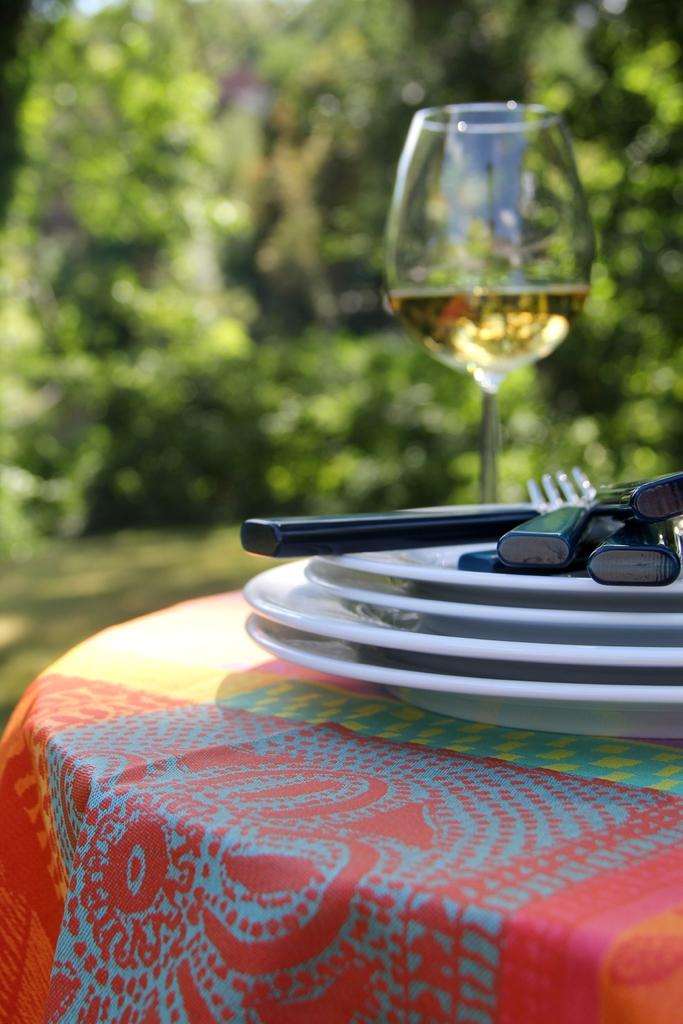How many plates are visible in the image? There are four plates in the image. What utensils are present in the image? There are spoons and forks in the image. What type of container is in the image? There is a glass in the image. Where are all these objects located? All of these objects are on a table. How are the goldfish being cared for in the image? There are no goldfish present in the image, so it is not possible to answer that question. 